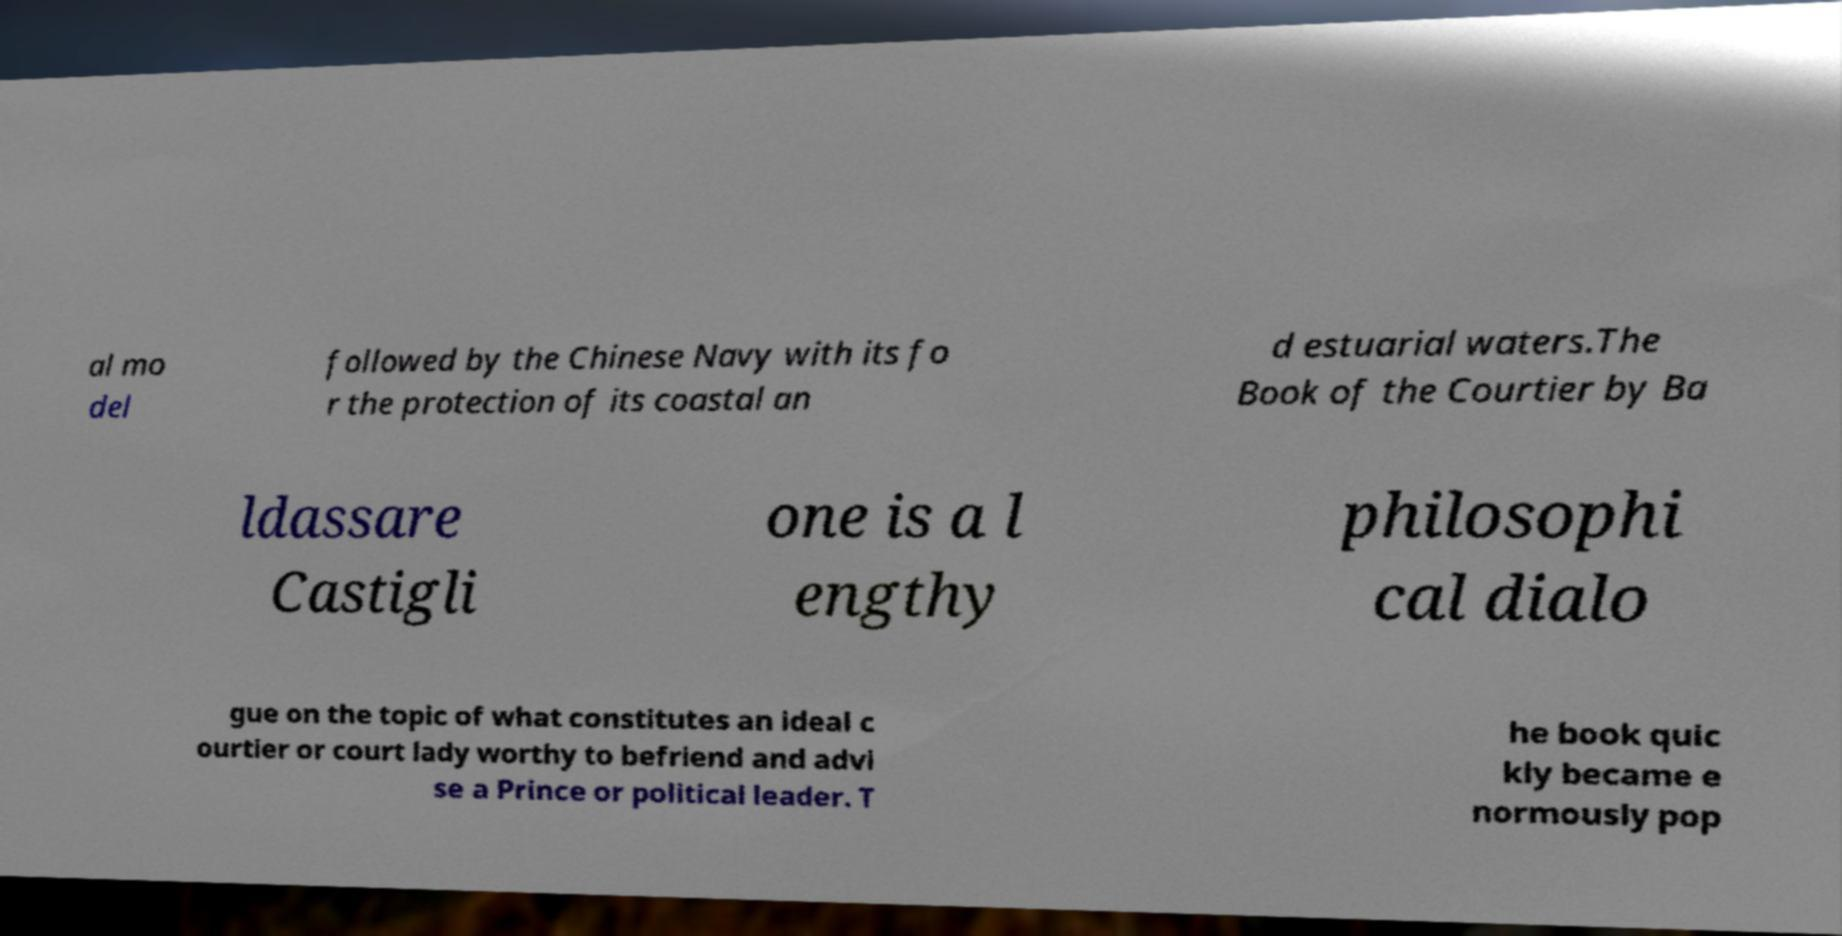For documentation purposes, I need the text within this image transcribed. Could you provide that? al mo del followed by the Chinese Navy with its fo r the protection of its coastal an d estuarial waters.The Book of the Courtier by Ba ldassare Castigli one is a l engthy philosophi cal dialo gue on the topic of what constitutes an ideal c ourtier or court lady worthy to befriend and advi se a Prince or political leader. T he book quic kly became e normously pop 